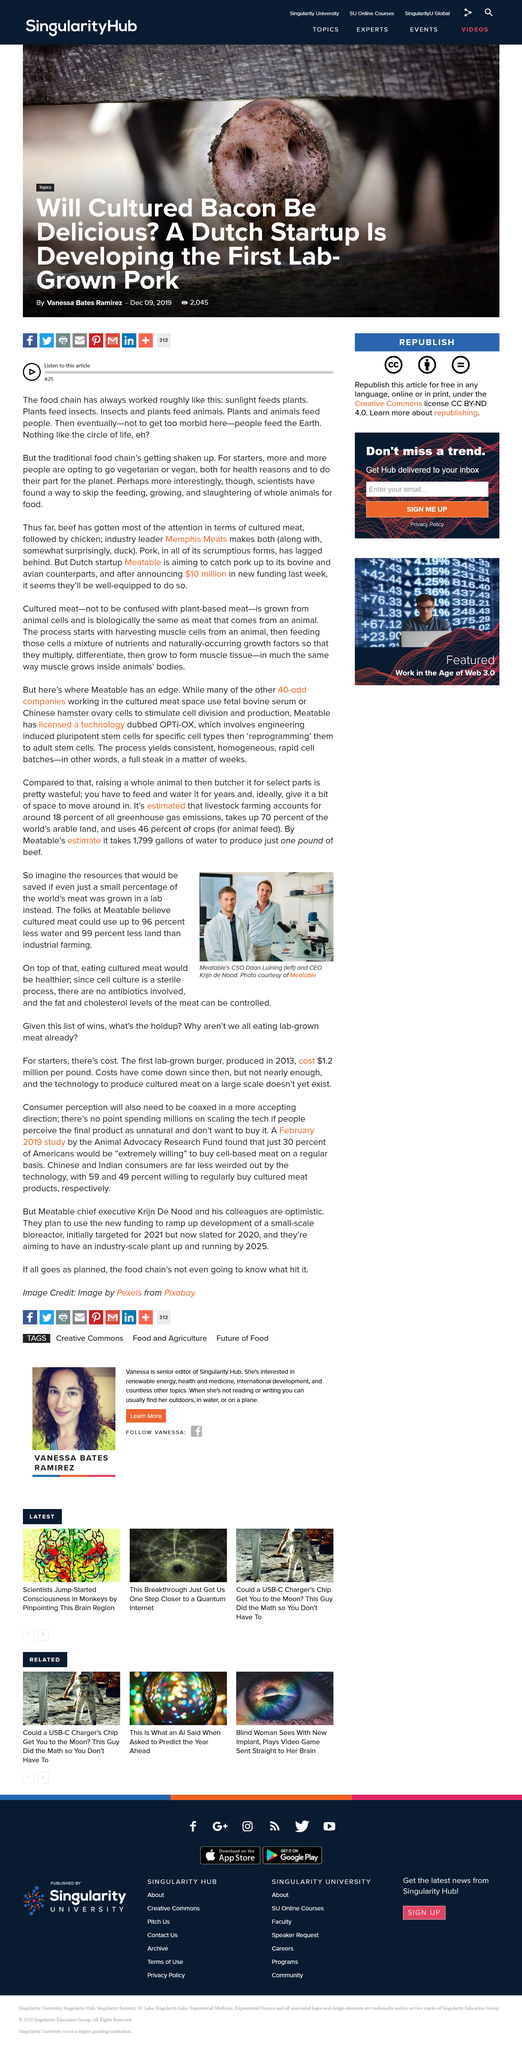Give some essential details in this illustration. The use of water and land will be significantly reduced through the practice of growing meat in a laboratory, making it an environmentally friendly alternative to traditional meat production methods. The use of land for growing meat in a lab will result in a 99% reduction of land usage, allowing for more sustainable and efficient agriculture practices. The CEO of Meatable, Krijn de Nood, believes that cultured meat is a healthier alternative to traditional animal-based meat. 